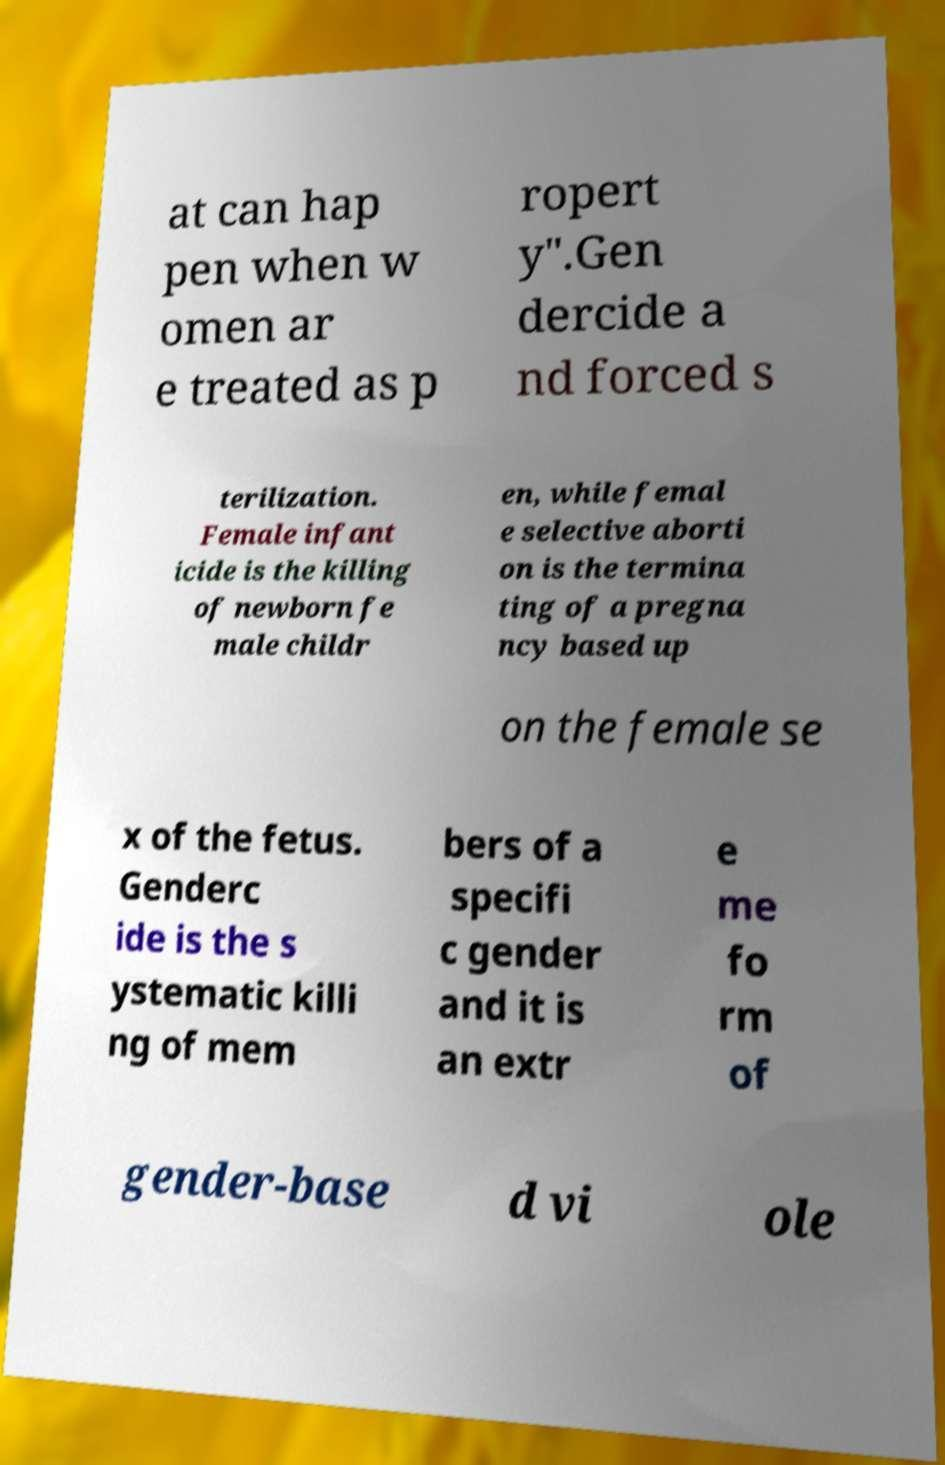Can you read and provide the text displayed in the image?This photo seems to have some interesting text. Can you extract and type it out for me? at can hap pen when w omen ar e treated as p ropert y".Gen dercide a nd forced s terilization. Female infant icide is the killing of newborn fe male childr en, while femal e selective aborti on is the termina ting of a pregna ncy based up on the female se x of the fetus. Genderc ide is the s ystematic killi ng of mem bers of a specifi c gender and it is an extr e me fo rm of gender-base d vi ole 